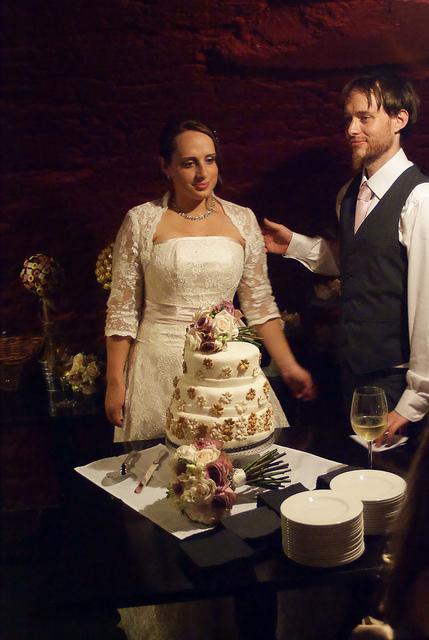Are two men getting married?
Write a very short answer. No. What style of wedding dress is she wearing?
Be succinct. Straight. What has this couple recently done?
Answer briefly. Married. What is this event?
Keep it brief. Wedding. 